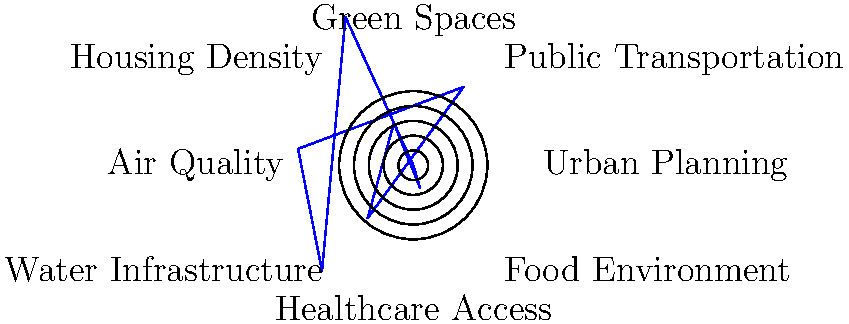In the polar rose diagram above, which urban planning factor shows the strongest positive correlation with public health outcomes, and what might this imply about early 20th-century health policies? To answer this question, we need to analyze the polar rose diagram and interpret its implications:

1. The diagram represents various urban planning factors and their relationship to public health outcomes.

2. The length of each "petal" in the rose diagram indicates the strength of the relationship between the factor and public health outcomes.

3. Examining the diagram, we can see that the longest petal corresponds to "Public Transportation" in the northeast direction.

4. This suggests that public transportation had the strongest positive correlation with public health outcomes among the factors presented.

5. Interpreting this in the context of early 20th-century health policies:
   a) The strong relationship between public transportation and health outcomes might imply that early 20th-century policies recognized the importance of mobility in accessing healthcare and other health-related resources.
   b) It could suggest that policies promoting public transportation infrastructure were effective in improving overall public health.
   c) This correlation might indicate that public transportation helped reduce overcrowding in urban areas, potentially decreasing the spread of communicable diseases.

6. The prominence of public transportation in this diagram aligns with the urbanization trends of the early 20th century, where efficient movement within growing cities became crucial for public health.
Answer: Public transportation, implying early 20th-century policies recognized the importance of urban mobility for public health. 